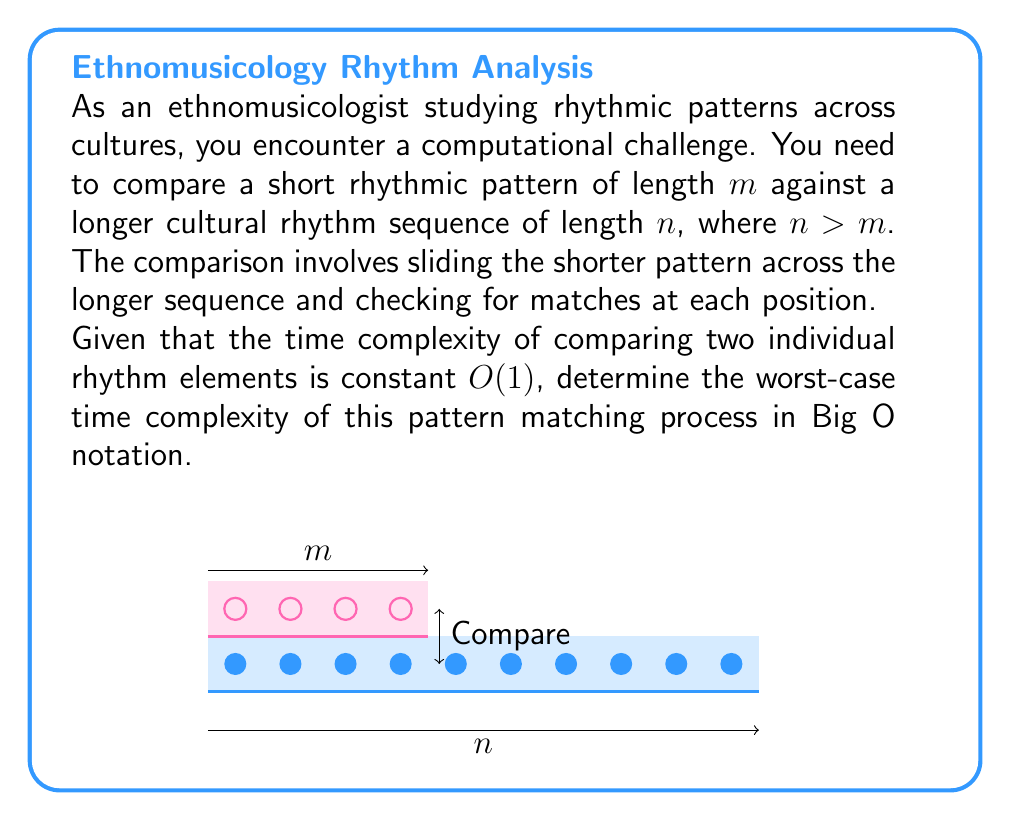What is the answer to this math problem? Let's approach this step-by-step:

1) The pattern of length $m$ needs to be compared against the longer sequence at every possible position.

2) The number of possible starting positions for comparison is $(n - m + 1)$. This is because the last valid position starts at index $(n - m)$ of the longer sequence.

3) At each of these positions, we need to compare all $m$ elements of the shorter pattern with the corresponding elements in the longer sequence.

4) The comparison of each element takes constant time $O(1)$, as given in the problem statement.

5) Therefore, for each starting position, we perform $m$ comparisons.

6) The total number of comparisons is thus:
   $$(n - m + 1) \cdot m$$

7) In the worst-case scenario, $m$ could be close to $n$ (but still smaller). In this case, the expression simplifies to:
   $$O((n - m + 1) \cdot m) = O(nm - m^2 + m) = O(nm)$$

8) However, when $m$ is significantly smaller than $n$, the complexity remains $O(nm)$.

Thus, the worst-case time complexity of this pattern matching process is $O(nm)$.
Answer: $O(nm)$ 